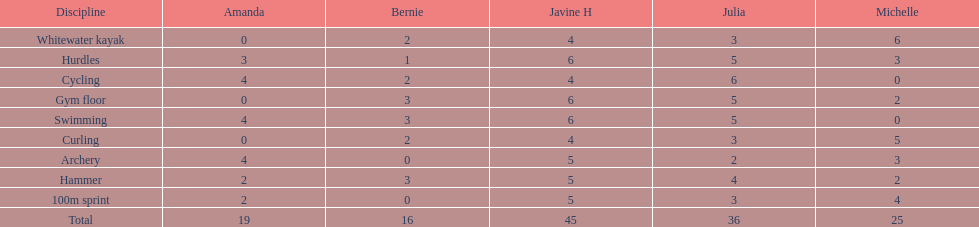What's the usual result for a 100m dash? 2.8. 